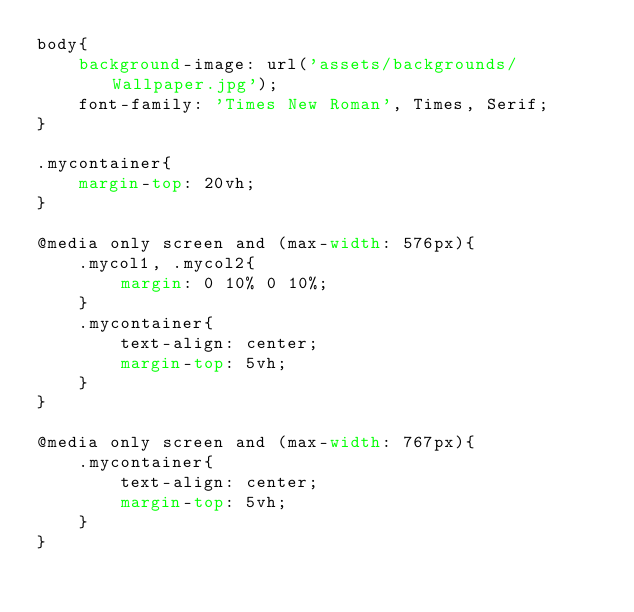<code> <loc_0><loc_0><loc_500><loc_500><_CSS_>body{
    background-image: url('assets/backgrounds/Wallpaper.jpg');
    font-family: 'Times New Roman', Times, Serif;
}

.mycontainer{
    margin-top: 20vh;
}

@media only screen and (max-width: 576px){
    .mycol1, .mycol2{
        margin: 0 10% 0 10%;
    }
    .mycontainer{
        text-align: center;
        margin-top: 5vh;
    }
}

@media only screen and (max-width: 767px){
    .mycontainer{
        text-align: center;
        margin-top: 5vh;
    }
}</code> 